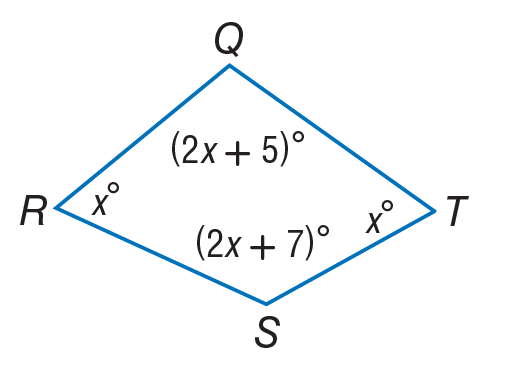Answer the mathemtical geometry problem and directly provide the correct option letter.
Question: Find m \angle T.
Choices: A: 58 B: 68 C: 121 D: 123 A 